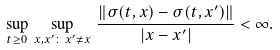<formula> <loc_0><loc_0><loc_500><loc_500>\sup _ { t \geq 0 } \, \sup _ { x , x ^ { \prime } \colon \, x ^ { \prime } \not = x } \, \frac { \| \sigma ( t , x ) - \sigma ( t , x ^ { \prime } ) \| } { | x - x ^ { \prime } | } < \infty .</formula> 